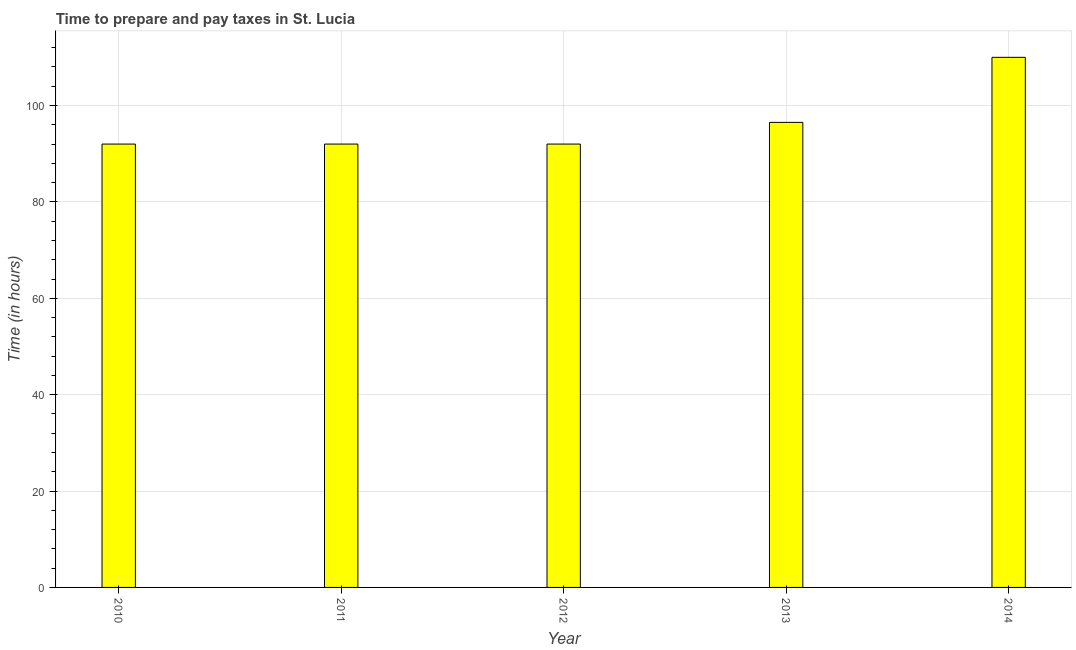Does the graph contain any zero values?
Your answer should be compact. No. What is the title of the graph?
Provide a short and direct response. Time to prepare and pay taxes in St. Lucia. What is the label or title of the X-axis?
Give a very brief answer. Year. What is the label or title of the Y-axis?
Provide a succinct answer. Time (in hours). What is the time to prepare and pay taxes in 2010?
Provide a succinct answer. 92. Across all years, what is the maximum time to prepare and pay taxes?
Offer a very short reply. 110. Across all years, what is the minimum time to prepare and pay taxes?
Your response must be concise. 92. In which year was the time to prepare and pay taxes minimum?
Give a very brief answer. 2010. What is the sum of the time to prepare and pay taxes?
Ensure brevity in your answer.  482.5. What is the average time to prepare and pay taxes per year?
Your response must be concise. 96.5. What is the median time to prepare and pay taxes?
Keep it short and to the point. 92. In how many years, is the time to prepare and pay taxes greater than 44 hours?
Offer a terse response. 5. What is the ratio of the time to prepare and pay taxes in 2011 to that in 2012?
Provide a short and direct response. 1. Is the difference between the time to prepare and pay taxes in 2010 and 2011 greater than the difference between any two years?
Provide a short and direct response. No. In how many years, is the time to prepare and pay taxes greater than the average time to prepare and pay taxes taken over all years?
Provide a short and direct response. 1. Are all the bars in the graph horizontal?
Ensure brevity in your answer.  No. How many years are there in the graph?
Keep it short and to the point. 5. What is the difference between two consecutive major ticks on the Y-axis?
Offer a very short reply. 20. What is the Time (in hours) in 2010?
Make the answer very short. 92. What is the Time (in hours) in 2011?
Offer a very short reply. 92. What is the Time (in hours) of 2012?
Provide a succinct answer. 92. What is the Time (in hours) in 2013?
Offer a terse response. 96.5. What is the Time (in hours) in 2014?
Offer a terse response. 110. What is the difference between the Time (in hours) in 2010 and 2011?
Provide a short and direct response. 0. What is the difference between the Time (in hours) in 2010 and 2012?
Ensure brevity in your answer.  0. What is the difference between the Time (in hours) in 2010 and 2013?
Give a very brief answer. -4.5. What is the difference between the Time (in hours) in 2010 and 2014?
Your response must be concise. -18. What is the difference between the Time (in hours) in 2011 and 2013?
Give a very brief answer. -4.5. What is the ratio of the Time (in hours) in 2010 to that in 2012?
Provide a succinct answer. 1. What is the ratio of the Time (in hours) in 2010 to that in 2013?
Offer a terse response. 0.95. What is the ratio of the Time (in hours) in 2010 to that in 2014?
Your answer should be very brief. 0.84. What is the ratio of the Time (in hours) in 2011 to that in 2012?
Make the answer very short. 1. What is the ratio of the Time (in hours) in 2011 to that in 2013?
Make the answer very short. 0.95. What is the ratio of the Time (in hours) in 2011 to that in 2014?
Make the answer very short. 0.84. What is the ratio of the Time (in hours) in 2012 to that in 2013?
Offer a very short reply. 0.95. What is the ratio of the Time (in hours) in 2012 to that in 2014?
Offer a very short reply. 0.84. What is the ratio of the Time (in hours) in 2013 to that in 2014?
Your response must be concise. 0.88. 